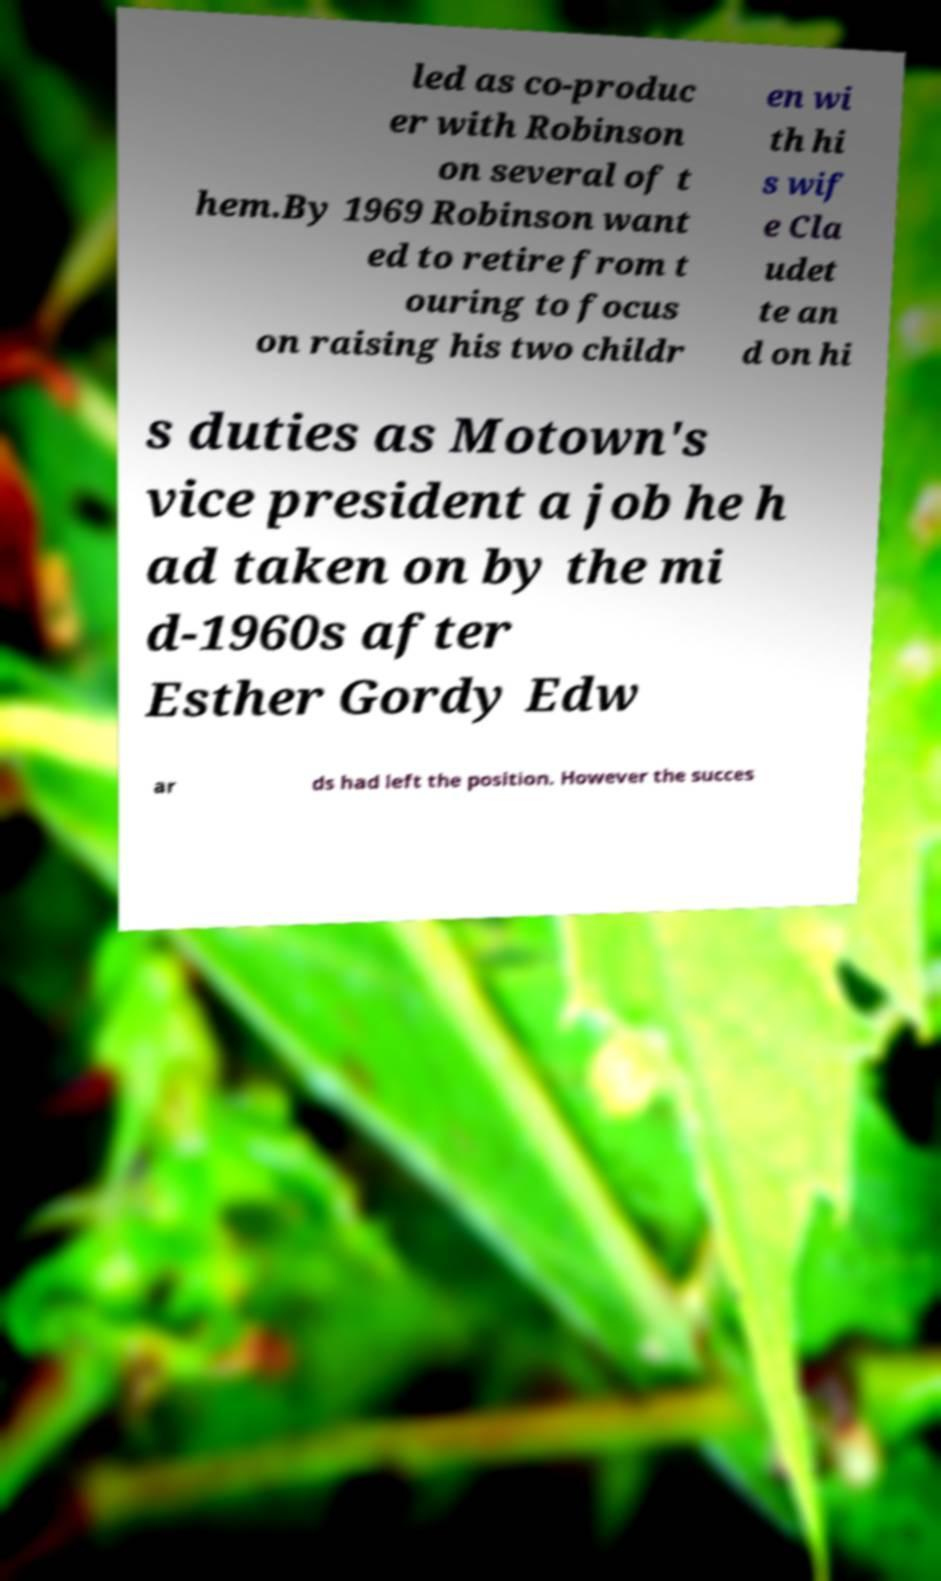Can you read and provide the text displayed in the image?This photo seems to have some interesting text. Can you extract and type it out for me? led as co-produc er with Robinson on several of t hem.By 1969 Robinson want ed to retire from t ouring to focus on raising his two childr en wi th hi s wif e Cla udet te an d on hi s duties as Motown's vice president a job he h ad taken on by the mi d-1960s after Esther Gordy Edw ar ds had left the position. However the succes 